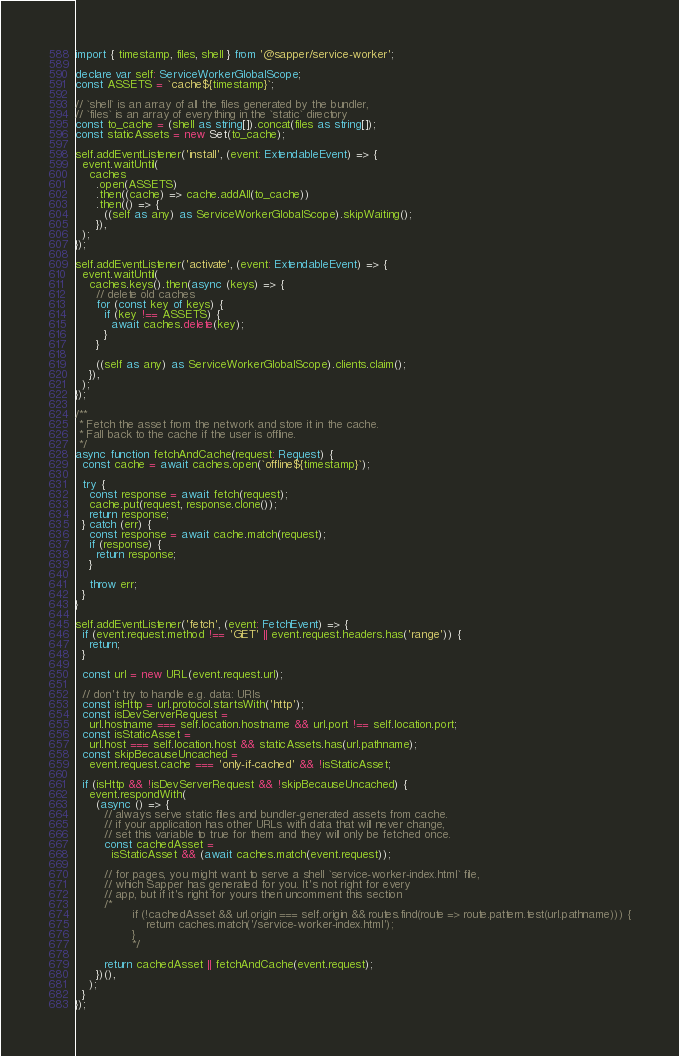<code> <loc_0><loc_0><loc_500><loc_500><_TypeScript_>import { timestamp, files, shell } from '@sapper/service-worker';

declare var self: ServiceWorkerGlobalScope;
const ASSETS = `cache${timestamp}`;

// `shell` is an array of all the files generated by the bundler,
// `files` is an array of everything in the `static` directory
const to_cache = (shell as string[]).concat(files as string[]);
const staticAssets = new Set(to_cache);

self.addEventListener('install', (event: ExtendableEvent) => {
  event.waitUntil(
    caches
      .open(ASSETS)
      .then((cache) => cache.addAll(to_cache))
      .then(() => {
        ((self as any) as ServiceWorkerGlobalScope).skipWaiting();
      }),
  );
});

self.addEventListener('activate', (event: ExtendableEvent) => {
  event.waitUntil(
    caches.keys().then(async (keys) => {
      // delete old caches
      for (const key of keys) {
        if (key !== ASSETS) {
          await caches.delete(key);
        }
      }

      ((self as any) as ServiceWorkerGlobalScope).clients.claim();
    }),
  );
});

/**
 * Fetch the asset from the network and store it in the cache.
 * Fall back to the cache if the user is offline.
 */
async function fetchAndCache(request: Request) {
  const cache = await caches.open(`offline${timestamp}`);

  try {
    const response = await fetch(request);
    cache.put(request, response.clone());
    return response;
  } catch (err) {
    const response = await cache.match(request);
    if (response) {
      return response;
    }

    throw err;
  }
}

self.addEventListener('fetch', (event: FetchEvent) => {
  if (event.request.method !== 'GET' || event.request.headers.has('range')) {
    return;
  }

  const url = new URL(event.request.url);

  // don't try to handle e.g. data: URIs
  const isHttp = url.protocol.startsWith('http');
  const isDevServerRequest =
    url.hostname === self.location.hostname && url.port !== self.location.port;
  const isStaticAsset =
    url.host === self.location.host && staticAssets.has(url.pathname);
  const skipBecauseUncached =
    event.request.cache === 'only-if-cached' && !isStaticAsset;

  if (isHttp && !isDevServerRequest && !skipBecauseUncached) {
    event.respondWith(
      (async () => {
        // always serve static files and bundler-generated assets from cache.
        // if your application has other URLs with data that will never change,
        // set this variable to true for them and they will only be fetched once.
        const cachedAsset =
          isStaticAsset && (await caches.match(event.request));

        // for pages, you might want to serve a shell `service-worker-index.html` file,
        // which Sapper has generated for you. It's not right for every
        // app, but if it's right for yours then uncomment this section
        /*
				if (!cachedAsset && url.origin === self.origin && routes.find(route => route.pattern.test(url.pathname))) {
					return caches.match('/service-worker-index.html');
				}
				*/

        return cachedAsset || fetchAndCache(event.request);
      })(),
    );
  }
});
</code> 